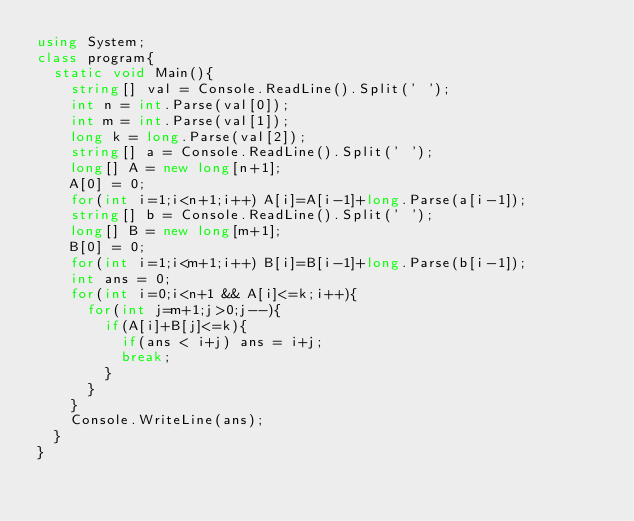Convert code to text. <code><loc_0><loc_0><loc_500><loc_500><_C#_>using System;
class program{
  static void Main(){
    string[] val = Console.ReadLine().Split(' ');
    int n = int.Parse(val[0]);
    int m = int.Parse(val[1]);
    long k = long.Parse(val[2]);
    string[] a = Console.ReadLine().Split(' ');
    long[] A = new long[n+1];
    A[0] = 0;
    for(int i=1;i<n+1;i++) A[i]=A[i-1]+long.Parse(a[i-1]);
    string[] b = Console.ReadLine().Split(' ');
    long[] B = new long[m+1];
    B[0] = 0;
    for(int i=1;i<m+1;i++) B[i]=B[i-1]+long.Parse(b[i-1]);
    int ans = 0;
    for(int i=0;i<n+1 && A[i]<=k;i++){
      for(int j=m+1;j>0;j--){
        if(A[i]+B[j]<=k){
          if(ans < i+j) ans = i+j;
          break;
        }
      }
    }
    Console.WriteLine(ans);
  }
}</code> 